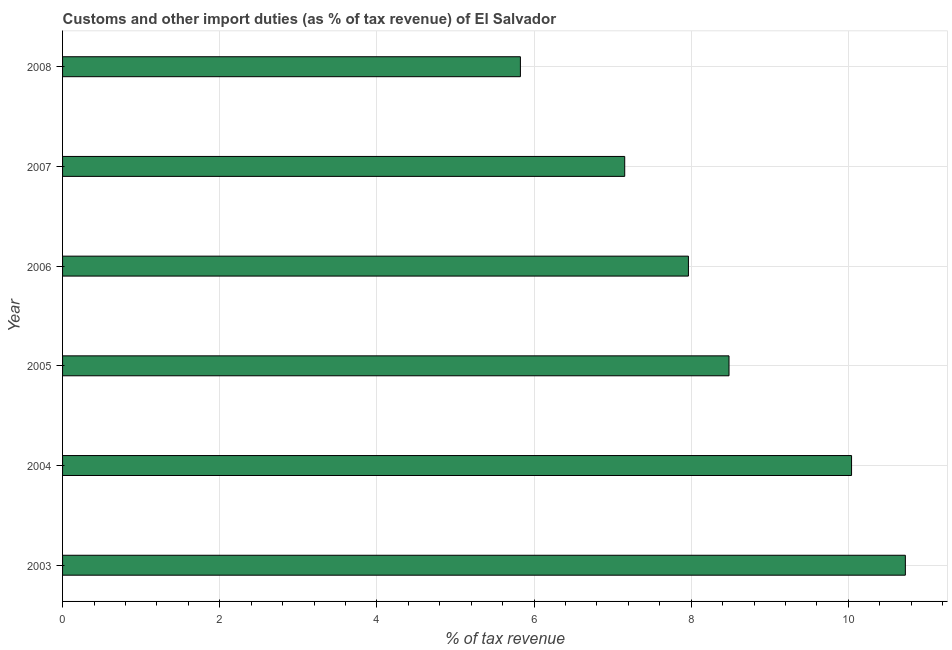What is the title of the graph?
Ensure brevity in your answer.  Customs and other import duties (as % of tax revenue) of El Salvador. What is the label or title of the X-axis?
Offer a terse response. % of tax revenue. What is the label or title of the Y-axis?
Your answer should be compact. Year. What is the customs and other import duties in 2005?
Ensure brevity in your answer.  8.48. Across all years, what is the maximum customs and other import duties?
Offer a terse response. 10.73. Across all years, what is the minimum customs and other import duties?
Offer a terse response. 5.83. In which year was the customs and other import duties maximum?
Make the answer very short. 2003. In which year was the customs and other import duties minimum?
Your answer should be very brief. 2008. What is the sum of the customs and other import duties?
Your response must be concise. 50.2. What is the difference between the customs and other import duties in 2006 and 2008?
Provide a short and direct response. 2.14. What is the average customs and other import duties per year?
Offer a very short reply. 8.37. What is the median customs and other import duties?
Keep it short and to the point. 8.22. What is the ratio of the customs and other import duties in 2003 to that in 2008?
Make the answer very short. 1.84. What is the difference between the highest and the second highest customs and other import duties?
Keep it short and to the point. 0.69. What is the difference between the highest and the lowest customs and other import duties?
Give a very brief answer. 4.9. In how many years, is the customs and other import duties greater than the average customs and other import duties taken over all years?
Provide a succinct answer. 3. Are all the bars in the graph horizontal?
Offer a very short reply. Yes. What is the difference between two consecutive major ticks on the X-axis?
Your response must be concise. 2. What is the % of tax revenue of 2003?
Offer a terse response. 10.73. What is the % of tax revenue of 2004?
Your answer should be compact. 10.04. What is the % of tax revenue of 2005?
Keep it short and to the point. 8.48. What is the % of tax revenue in 2006?
Provide a short and direct response. 7.97. What is the % of tax revenue in 2007?
Keep it short and to the point. 7.15. What is the % of tax revenue in 2008?
Offer a very short reply. 5.83. What is the difference between the % of tax revenue in 2003 and 2004?
Your answer should be compact. 0.68. What is the difference between the % of tax revenue in 2003 and 2005?
Make the answer very short. 2.24. What is the difference between the % of tax revenue in 2003 and 2006?
Give a very brief answer. 2.76. What is the difference between the % of tax revenue in 2003 and 2007?
Your response must be concise. 3.57. What is the difference between the % of tax revenue in 2003 and 2008?
Offer a very short reply. 4.9. What is the difference between the % of tax revenue in 2004 and 2005?
Give a very brief answer. 1.56. What is the difference between the % of tax revenue in 2004 and 2006?
Offer a terse response. 2.08. What is the difference between the % of tax revenue in 2004 and 2007?
Your answer should be very brief. 2.89. What is the difference between the % of tax revenue in 2004 and 2008?
Keep it short and to the point. 4.21. What is the difference between the % of tax revenue in 2005 and 2006?
Provide a succinct answer. 0.52. What is the difference between the % of tax revenue in 2005 and 2007?
Your response must be concise. 1.33. What is the difference between the % of tax revenue in 2005 and 2008?
Keep it short and to the point. 2.66. What is the difference between the % of tax revenue in 2006 and 2007?
Ensure brevity in your answer.  0.81. What is the difference between the % of tax revenue in 2006 and 2008?
Your answer should be compact. 2.14. What is the difference between the % of tax revenue in 2007 and 2008?
Ensure brevity in your answer.  1.33. What is the ratio of the % of tax revenue in 2003 to that in 2004?
Offer a very short reply. 1.07. What is the ratio of the % of tax revenue in 2003 to that in 2005?
Provide a succinct answer. 1.26. What is the ratio of the % of tax revenue in 2003 to that in 2006?
Your response must be concise. 1.35. What is the ratio of the % of tax revenue in 2003 to that in 2007?
Keep it short and to the point. 1.5. What is the ratio of the % of tax revenue in 2003 to that in 2008?
Your response must be concise. 1.84. What is the ratio of the % of tax revenue in 2004 to that in 2005?
Ensure brevity in your answer.  1.18. What is the ratio of the % of tax revenue in 2004 to that in 2006?
Your response must be concise. 1.26. What is the ratio of the % of tax revenue in 2004 to that in 2007?
Ensure brevity in your answer.  1.4. What is the ratio of the % of tax revenue in 2004 to that in 2008?
Offer a very short reply. 1.72. What is the ratio of the % of tax revenue in 2005 to that in 2006?
Keep it short and to the point. 1.06. What is the ratio of the % of tax revenue in 2005 to that in 2007?
Make the answer very short. 1.19. What is the ratio of the % of tax revenue in 2005 to that in 2008?
Ensure brevity in your answer.  1.46. What is the ratio of the % of tax revenue in 2006 to that in 2007?
Offer a terse response. 1.11. What is the ratio of the % of tax revenue in 2006 to that in 2008?
Your response must be concise. 1.37. What is the ratio of the % of tax revenue in 2007 to that in 2008?
Provide a succinct answer. 1.23. 